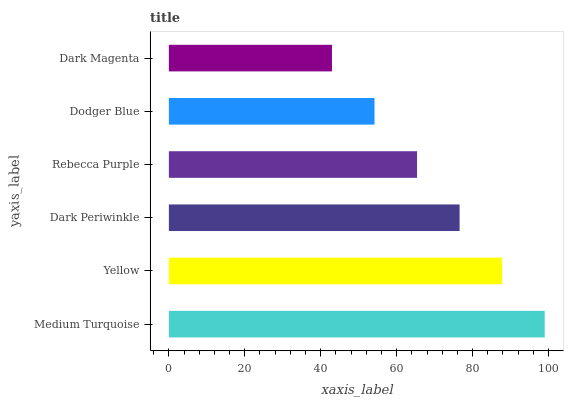Is Dark Magenta the minimum?
Answer yes or no. Yes. Is Medium Turquoise the maximum?
Answer yes or no. Yes. Is Yellow the minimum?
Answer yes or no. No. Is Yellow the maximum?
Answer yes or no. No. Is Medium Turquoise greater than Yellow?
Answer yes or no. Yes. Is Yellow less than Medium Turquoise?
Answer yes or no. Yes. Is Yellow greater than Medium Turquoise?
Answer yes or no. No. Is Medium Turquoise less than Yellow?
Answer yes or no. No. Is Dark Periwinkle the high median?
Answer yes or no. Yes. Is Rebecca Purple the low median?
Answer yes or no. Yes. Is Yellow the high median?
Answer yes or no. No. Is Yellow the low median?
Answer yes or no. No. 